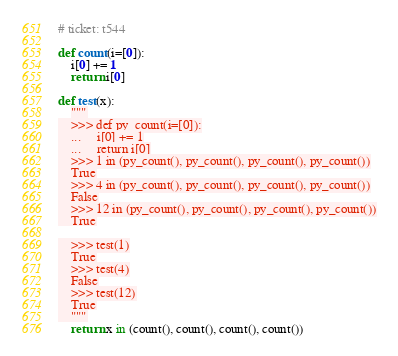Convert code to text. <code><loc_0><loc_0><loc_500><loc_500><_Cython_># ticket: t544

def count(i=[0]):
    i[0] += 1
    return i[0]

def test(x):
    """
    >>> def py_count(i=[0]):
    ...     i[0] += 1
    ...     return i[0]
    >>> 1 in (py_count(), py_count(), py_count(), py_count())
    True
    >>> 4 in (py_count(), py_count(), py_count(), py_count())
    False
    >>> 12 in (py_count(), py_count(), py_count(), py_count())
    True

    >>> test(1)
    True
    >>> test(4)
    False
    >>> test(12)
    True
    """
    return x in (count(), count(), count(), count())
</code> 